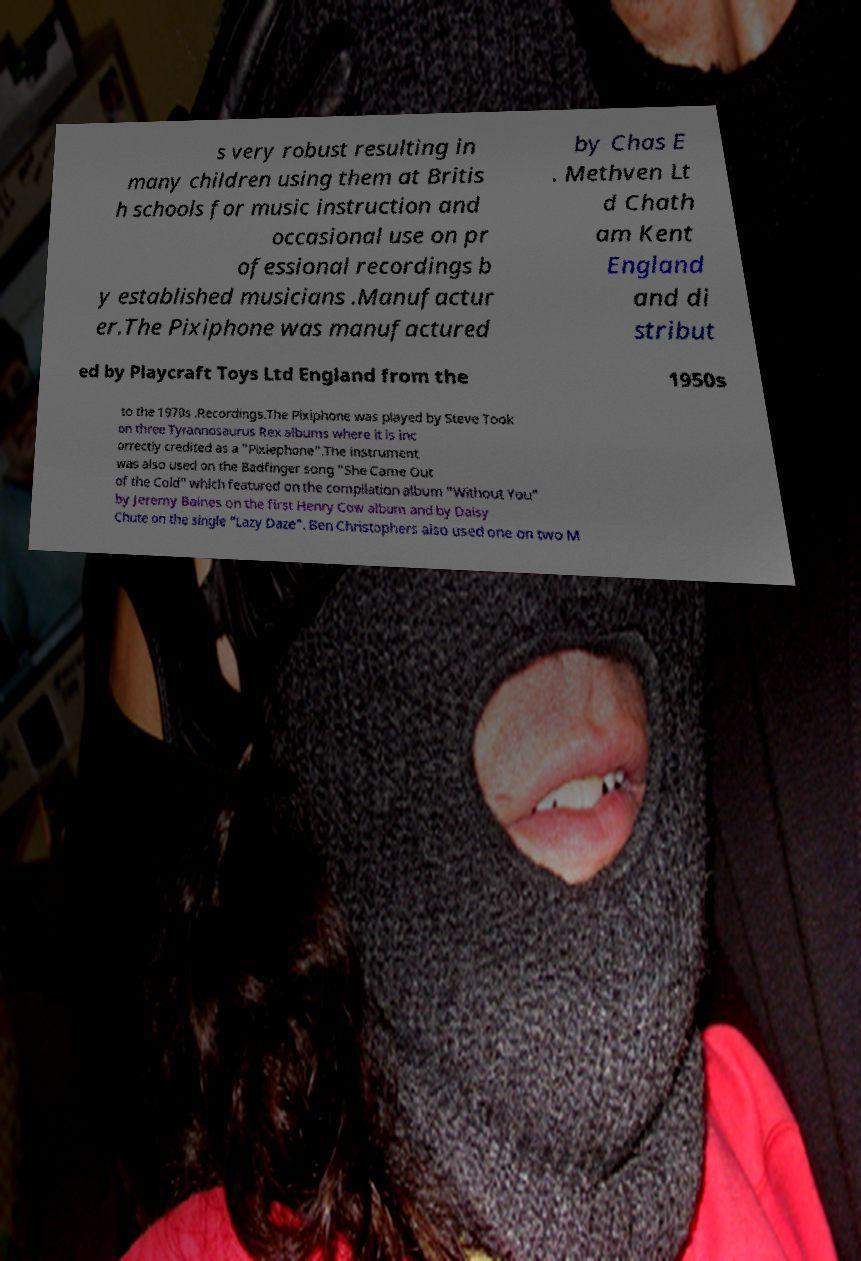For documentation purposes, I need the text within this image transcribed. Could you provide that? s very robust resulting in many children using them at Britis h schools for music instruction and occasional use on pr ofessional recordings b y established musicians .Manufactur er.The Pixiphone was manufactured by Chas E . Methven Lt d Chath am Kent England and di stribut ed by Playcraft Toys Ltd England from the 1950s to the 1970s .Recordings.The Pixiphone was played by Steve Took on three Tyrannosaurus Rex albums where it is inc orrectly credited as a "Pixiephone".The instrument was also used on the Badfinger song "She Came Out of the Cold" which featured on the compilation album "Without You" by Jeremy Baines on the first Henry Cow album and by Daisy Chute on the single "Lazy Daze". Ben Christophers also used one on two M 